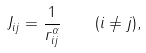Convert formula to latex. <formula><loc_0><loc_0><loc_500><loc_500>J _ { i j } = \frac { 1 } { r _ { i j } ^ { \alpha } } \quad ( i \neq j ) ,</formula> 